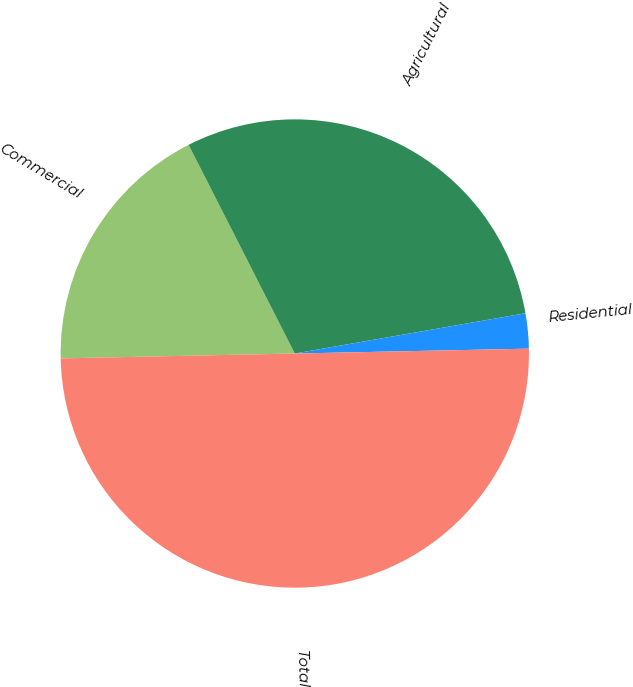<chart> <loc_0><loc_0><loc_500><loc_500><pie_chart><fcel>Commercial<fcel>Agricultural<fcel>Residential<fcel>Total<nl><fcel>17.84%<fcel>29.74%<fcel>2.42%<fcel>50.0%<nl></chart> 